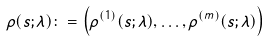<formula> <loc_0><loc_0><loc_500><loc_500>\rho ( s ; \lambda ) \colon = \left ( \rho ^ { ( 1 ) } ( s ; \lambda ) , \dots , \rho ^ { ( m ) } ( s ; \lambda ) \right )</formula> 